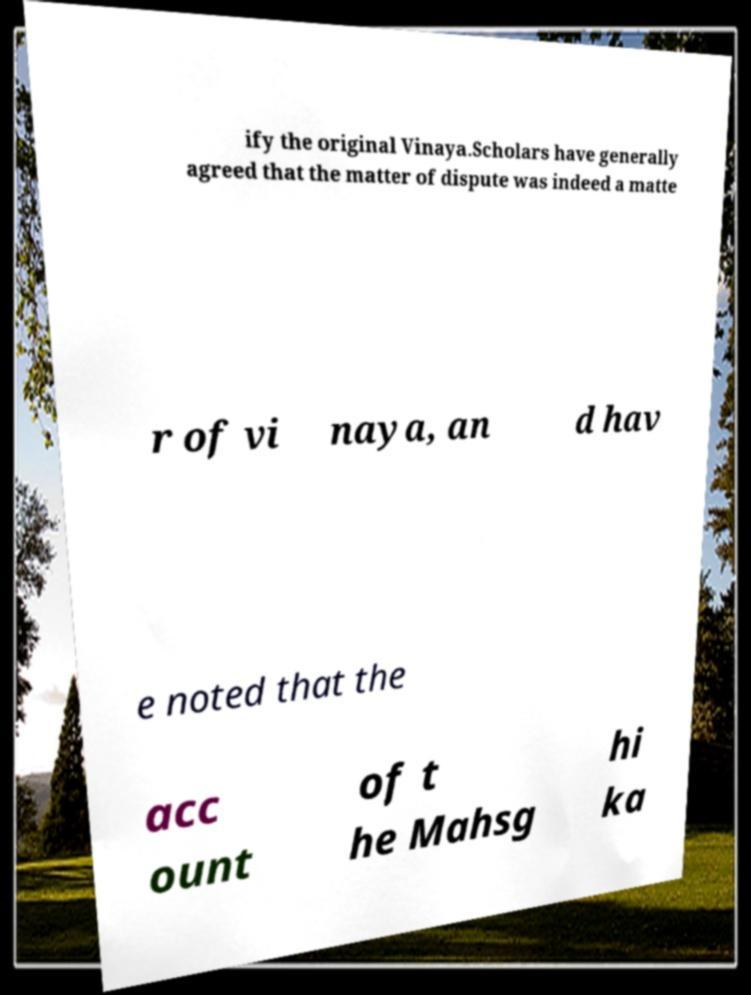Can you accurately transcribe the text from the provided image for me? ify the original Vinaya.Scholars have generally agreed that the matter of dispute was indeed a matte r of vi naya, an d hav e noted that the acc ount of t he Mahsg hi ka 